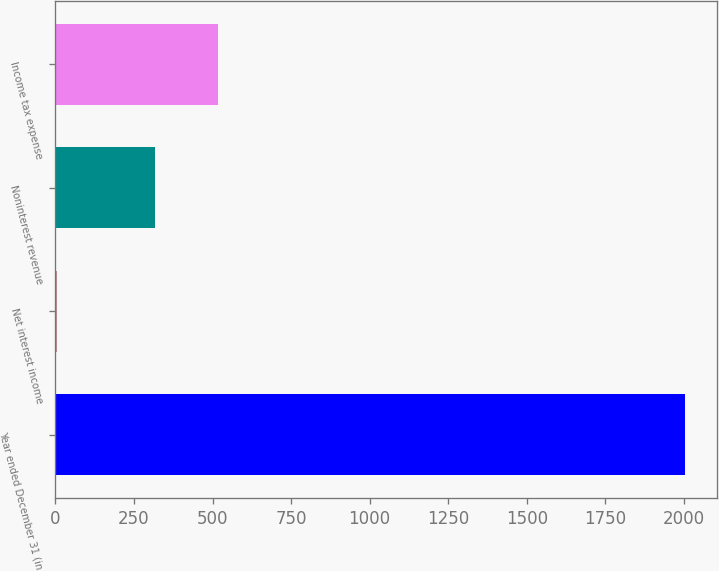<chart> <loc_0><loc_0><loc_500><loc_500><bar_chart><fcel>Year ended December 31 (in<fcel>Net interest income<fcel>Noninterest revenue<fcel>Income tax expense<nl><fcel>2004<fcel>6<fcel>317<fcel>516.8<nl></chart> 